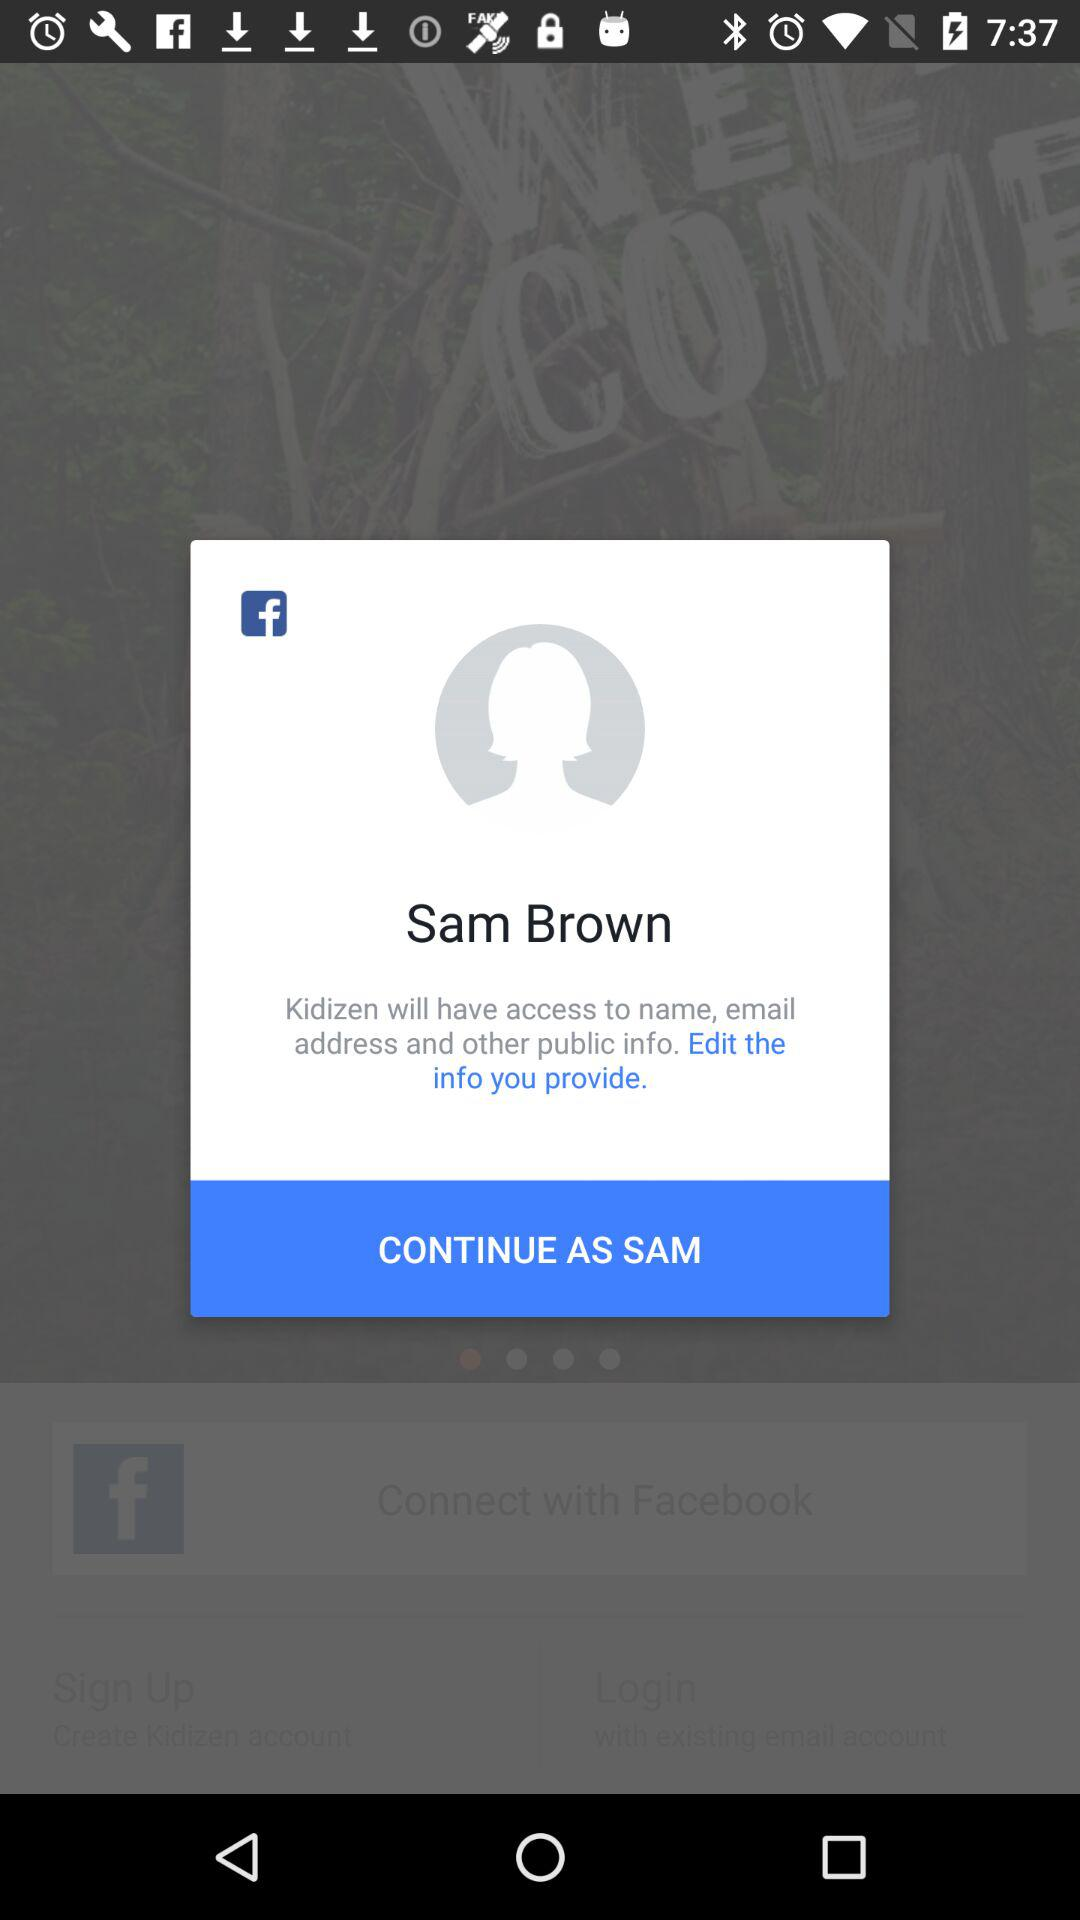Who will have access to the name, email address and other public information? The name, email address and other public information will be accessible to "Kidizen". 